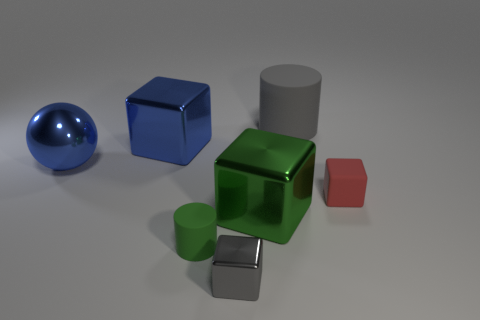Is the object that is on the right side of the gray cylinder made of the same material as the large gray thing?
Offer a terse response. Yes. What number of objects are either large spheres or blocks that are on the left side of the tiny matte cylinder?
Your answer should be very brief. 2. How many gray shiny objects are in front of the large object that is on the right side of the big shiny thing to the right of the tiny cylinder?
Your answer should be compact. 1. Do the tiny matte object that is behind the green matte object and the small gray metal object have the same shape?
Your response must be concise. Yes. Are there any things that are in front of the tiny thing right of the big rubber cylinder?
Make the answer very short. Yes. What number of large metal objects are there?
Provide a short and direct response. 3. What color is the rubber object that is on the right side of the green rubber cylinder and in front of the big cylinder?
Offer a terse response. Red. The other object that is the same shape as the gray rubber thing is what size?
Your response must be concise. Small. How many other green cylinders are the same size as the green cylinder?
Provide a short and direct response. 0. What material is the large green cube?
Offer a very short reply. Metal. 